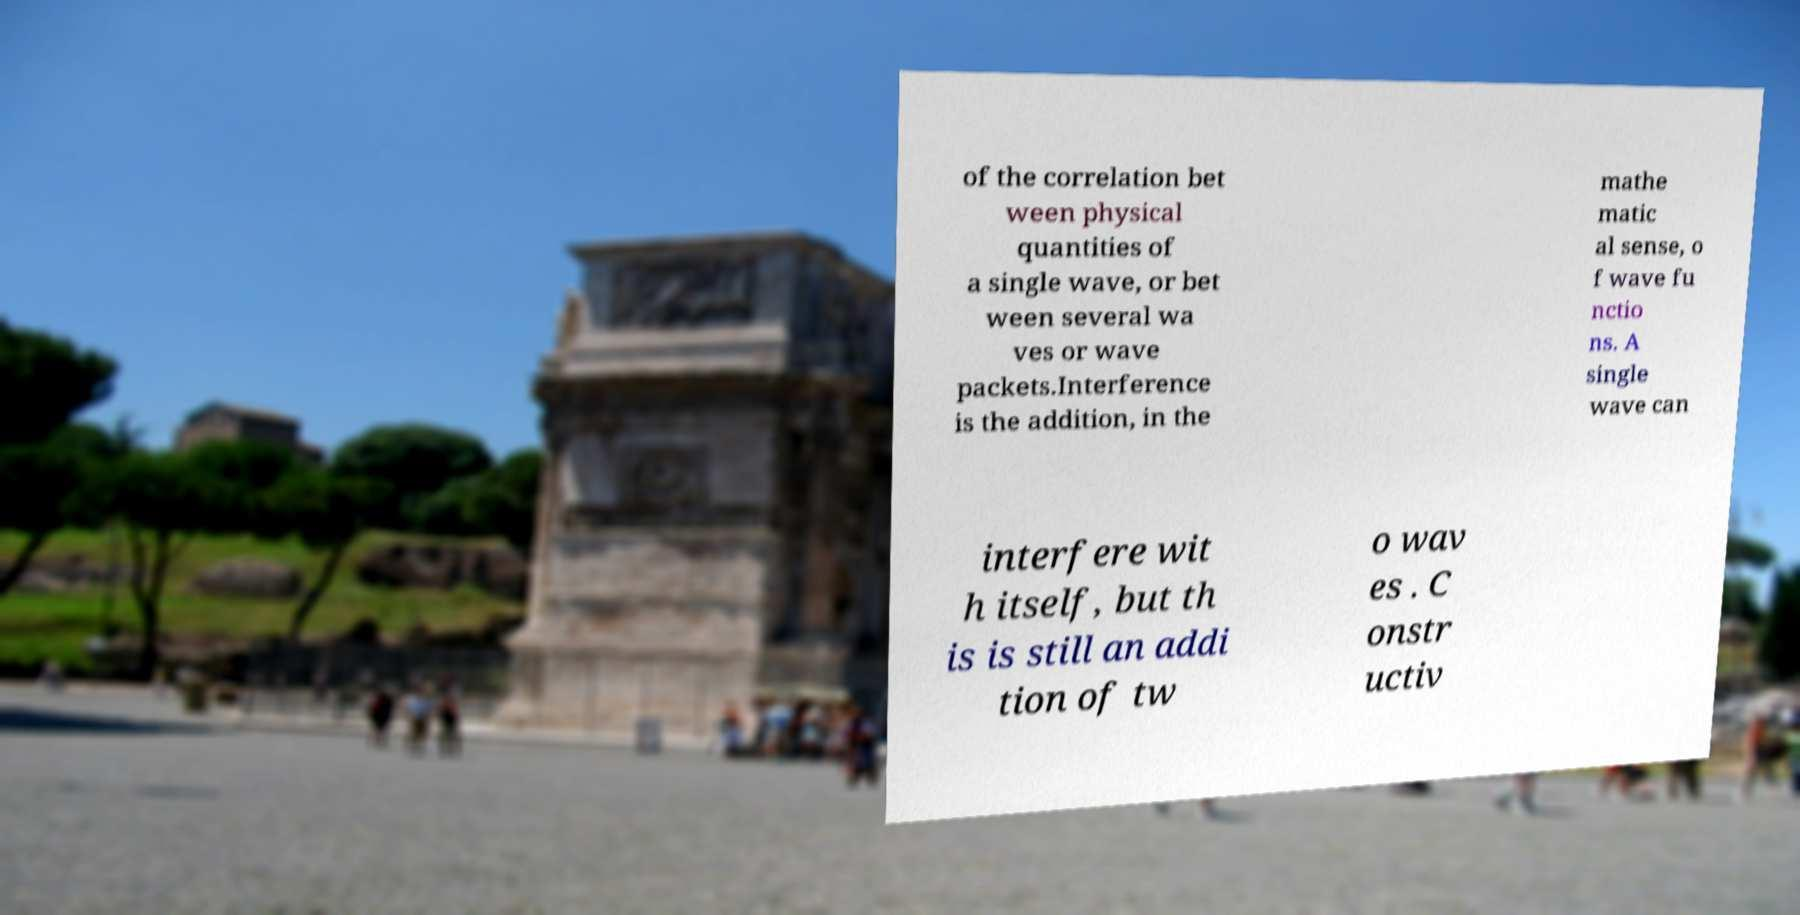Can you read and provide the text displayed in the image?This photo seems to have some interesting text. Can you extract and type it out for me? of the correlation bet ween physical quantities of a single wave, or bet ween several wa ves or wave packets.Interference is the addition, in the mathe matic al sense, o f wave fu nctio ns. A single wave can interfere wit h itself, but th is is still an addi tion of tw o wav es . C onstr uctiv 